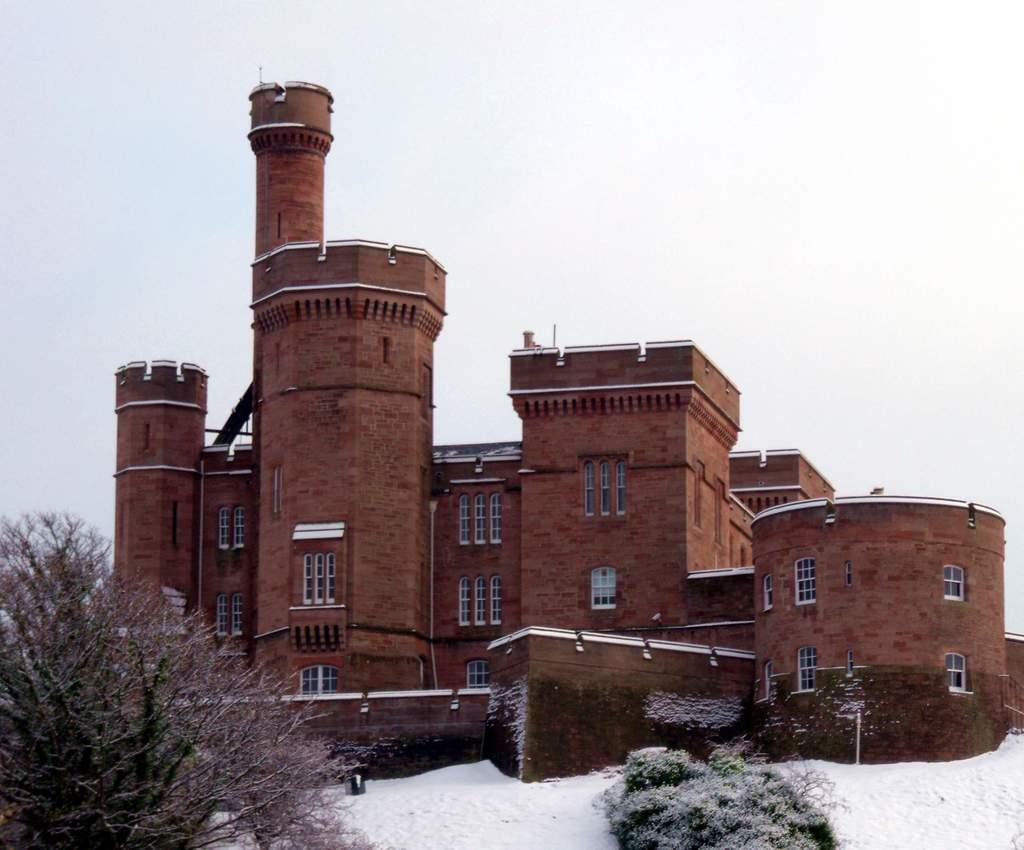What type of structure is visible in the image? There is a building in the image. What feature can be seen on the building? The building has windows. What is located in front of the building? There is a wall and snow in front of the building. What type of vegetation is present in front of the building? There are plants in front of the building. What is visible at the top of the image? The sky is visible at the top of the image. What type of bean is growing on the wall in the image? There are no beans growing on the wall in the image. What organization is hosting a party in front of the building in the image? There is no party or organization present in the image. 